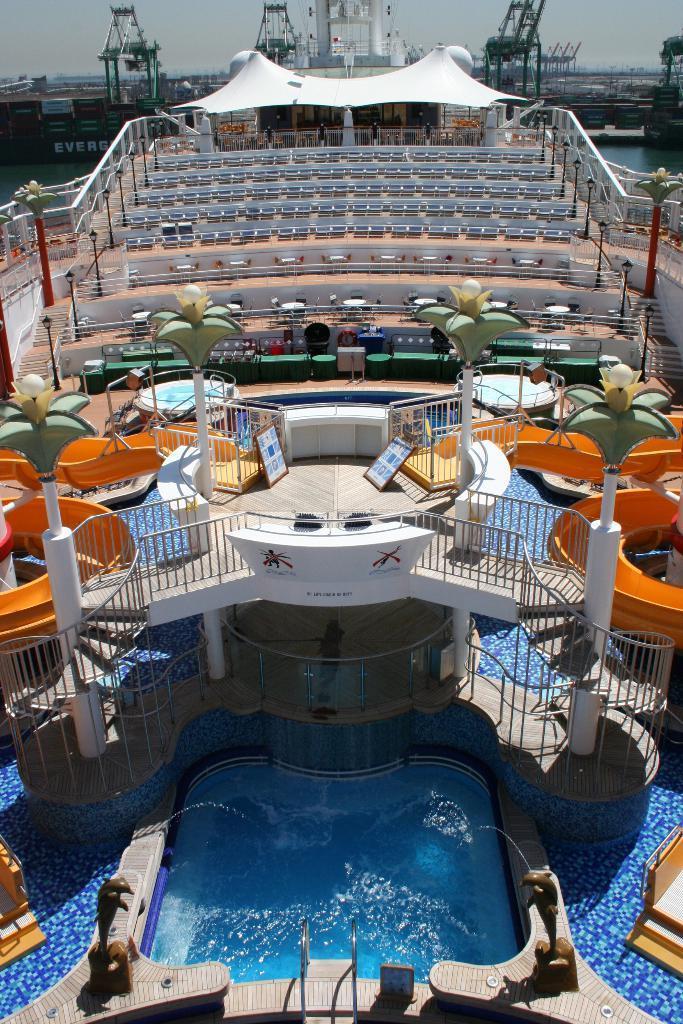Please provide a concise description of this image. In this picture we can see water, fence, boards, seats and in the background we can see the sky. 